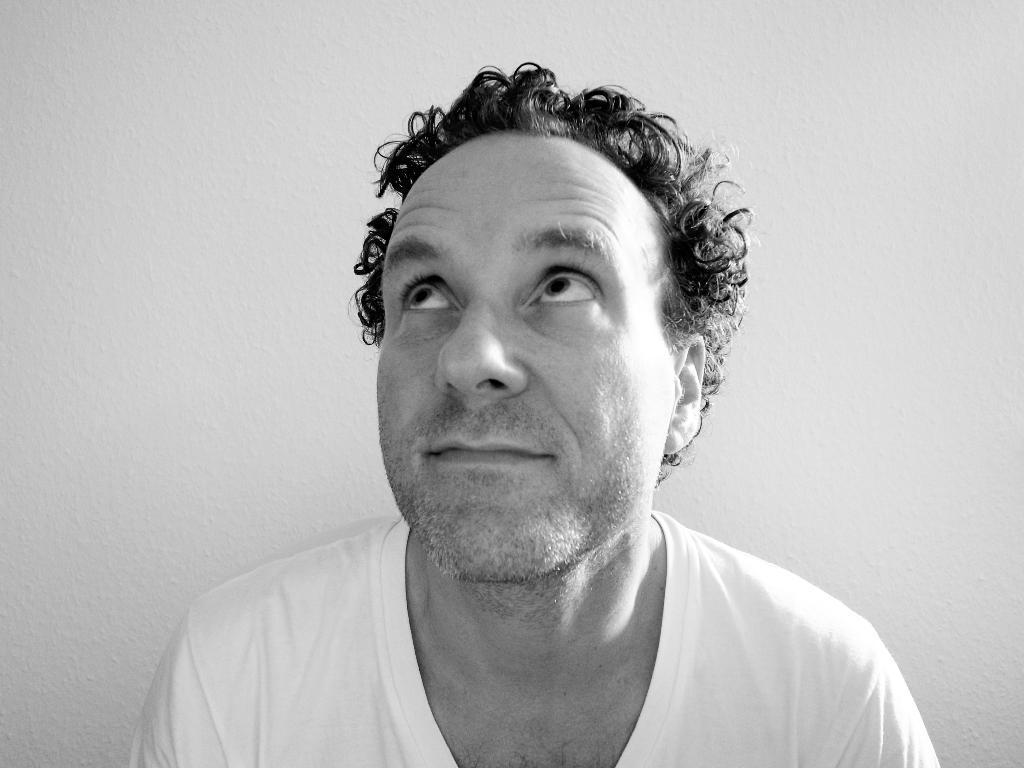Please provide a concise description of this image. In this image I can see a person. In the background there is a wall. 